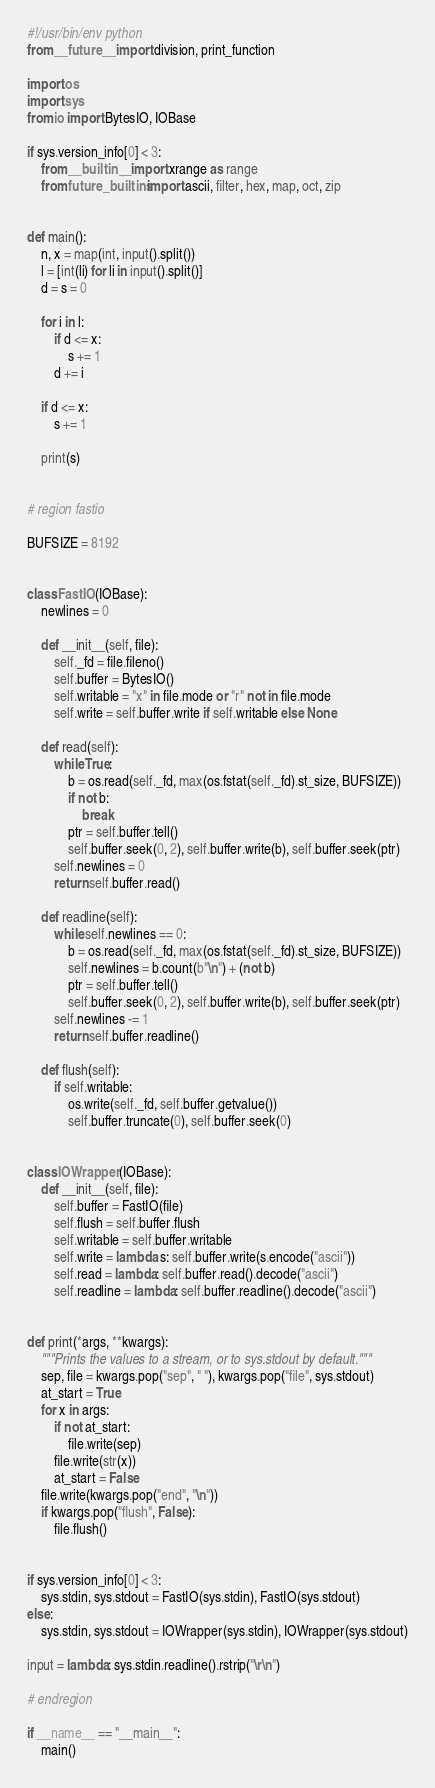<code> <loc_0><loc_0><loc_500><loc_500><_Python_>#!/usr/bin/env python
from __future__ import division, print_function

import os
import sys
from io import BytesIO, IOBase

if sys.version_info[0] < 3:
    from __builtin__ import xrange as range
    from future_builtins import ascii, filter, hex, map, oct, zip


def main():
    n, x = map(int, input().split())
    l = [int(li) for li in input().split()]
    d = s = 0

    for i in l:
        if d <= x:
            s += 1
        d += i

    if d <= x:
        s += 1

    print(s)


# region fastio

BUFSIZE = 8192


class FastIO(IOBase):
    newlines = 0

    def __init__(self, file):
        self._fd = file.fileno()
        self.buffer = BytesIO()
        self.writable = "x" in file.mode or "r" not in file.mode
        self.write = self.buffer.write if self.writable else None

    def read(self):
        while True:
            b = os.read(self._fd, max(os.fstat(self._fd).st_size, BUFSIZE))
            if not b:
                break
            ptr = self.buffer.tell()
            self.buffer.seek(0, 2), self.buffer.write(b), self.buffer.seek(ptr)
        self.newlines = 0
        return self.buffer.read()

    def readline(self):
        while self.newlines == 0:
            b = os.read(self._fd, max(os.fstat(self._fd).st_size, BUFSIZE))
            self.newlines = b.count(b"\n") + (not b)
            ptr = self.buffer.tell()
            self.buffer.seek(0, 2), self.buffer.write(b), self.buffer.seek(ptr)
        self.newlines -= 1
        return self.buffer.readline()

    def flush(self):
        if self.writable:
            os.write(self._fd, self.buffer.getvalue())
            self.buffer.truncate(0), self.buffer.seek(0)


class IOWrapper(IOBase):
    def __init__(self, file):
        self.buffer = FastIO(file)
        self.flush = self.buffer.flush
        self.writable = self.buffer.writable
        self.write = lambda s: self.buffer.write(s.encode("ascii"))
        self.read = lambda: self.buffer.read().decode("ascii")
        self.readline = lambda: self.buffer.readline().decode("ascii")


def print(*args, **kwargs):
    """Prints the values to a stream, or to sys.stdout by default."""
    sep, file = kwargs.pop("sep", " "), kwargs.pop("file", sys.stdout)
    at_start = True
    for x in args:
        if not at_start:
            file.write(sep)
        file.write(str(x))
        at_start = False
    file.write(kwargs.pop("end", "\n"))
    if kwargs.pop("flush", False):
        file.flush()


if sys.version_info[0] < 3:
    sys.stdin, sys.stdout = FastIO(sys.stdin), FastIO(sys.stdout)
else:
    sys.stdin, sys.stdout = IOWrapper(sys.stdin), IOWrapper(sys.stdout)

input = lambda: sys.stdin.readline().rstrip("\r\n")

# endregion

if __name__ == "__main__":
    main()
</code> 